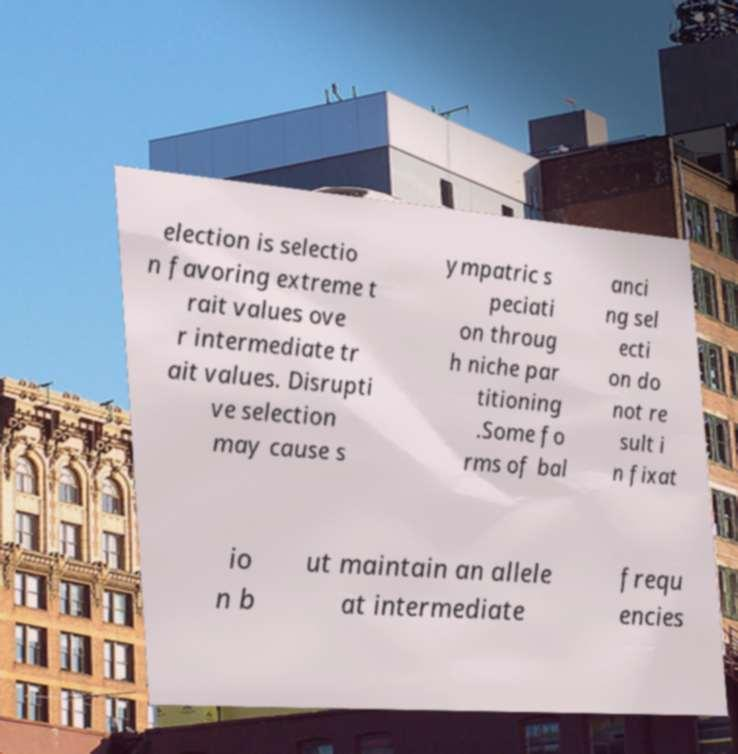Please identify and transcribe the text found in this image. election is selectio n favoring extreme t rait values ove r intermediate tr ait values. Disrupti ve selection may cause s ympatric s peciati on throug h niche par titioning .Some fo rms of bal anci ng sel ecti on do not re sult i n fixat io n b ut maintain an allele at intermediate frequ encies 